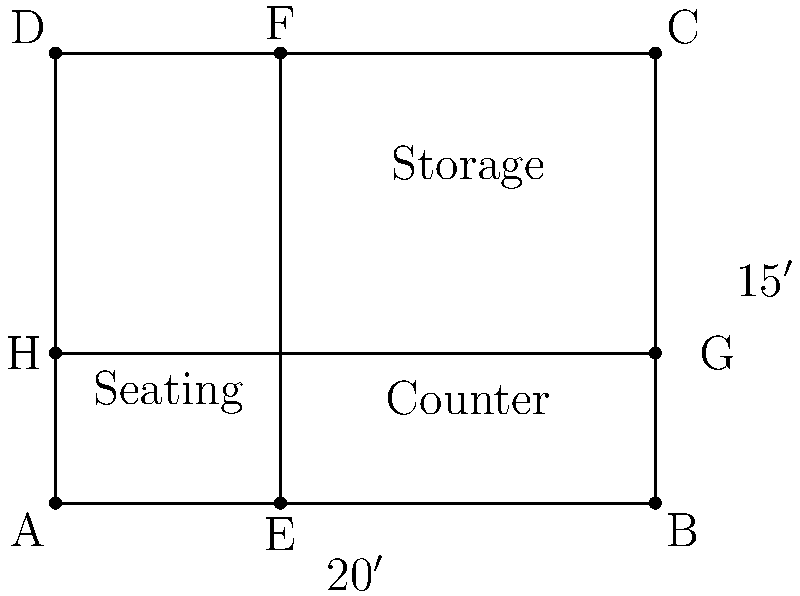A coffee shop owner wants to optimize their floor plan to maximize customer satisfaction and operational efficiency. The shop is rectangular, measuring 20 feet wide and 15 feet deep. The owner plans to divide the space into three areas: seating, counter, and storage. The seating area will be in the front of the shop, the counter in the middle, and storage in the back. If the depth of the seating area is represented by $x$ feet, find the optimal depth of the seating area that maximizes the product of the areas of all three sections. Let's approach this step-by-step:

1) First, we need to express the areas of each section in terms of $x$:
   - Seating area: $20x$ sq ft
   - Counter area: $20(5-x)$ sq ft (assuming the counter depth is 5 feet)
   - Storage area: $20(10-x)$ sq ft

2) The product of these areas is our objective function:
   $f(x) = 20x \cdot 20(5-x) \cdot 20(10-x) = 8000x(5-x)(10-x)$

3) Expand this expression:
   $f(x) = 8000(50x - 15x^2 + x^3) = 8000(x^3 - 15x^2 + 50x)$

4) To find the maximum, we need to find where $f'(x) = 0$:
   $f'(x) = 8000(3x^2 - 30x + 50)$

5) Set this equal to zero and solve:
   $3x^2 - 30x + 50 = 0$
   
   Using the quadratic formula: $x = \frac{30 \pm \sqrt{900 - 600}}{6} = \frac{30 \pm \sqrt{300}}{6}$

6) This gives us two solutions:
   $x_1 = \frac{30 + \sqrt{300}}{6} \approx 7.88$ and $x_2 = \frac{30 - \sqrt{300}}{6} \approx 2.12$

7) The second derivative $f''(x) = 8000(6x - 30)$ is positive when $x > 5$ and negative when $x < 5$.

8) Therefore, $x_2 \approx 2.12$ gives us the maximum.

9) Rounding to the nearest inch for practical purposes, the optimal depth of the seating area is 2 feet 1 inch or 25 inches.
Answer: 2 feet 1 inch (25 inches) 